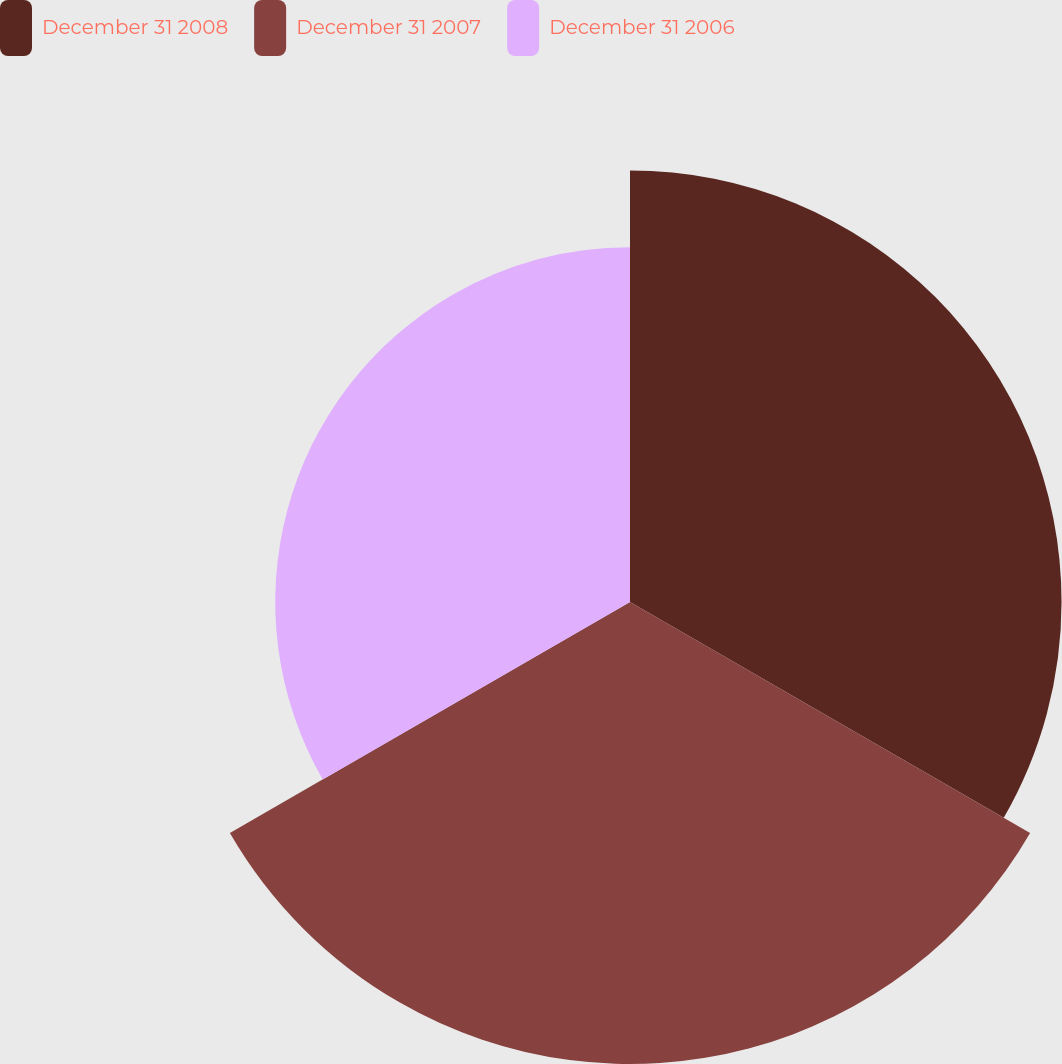<chart> <loc_0><loc_0><loc_500><loc_500><pie_chart><fcel>December 31 2008<fcel>December 31 2007<fcel>December 31 2006<nl><fcel>34.57%<fcel>37.01%<fcel>28.42%<nl></chart> 